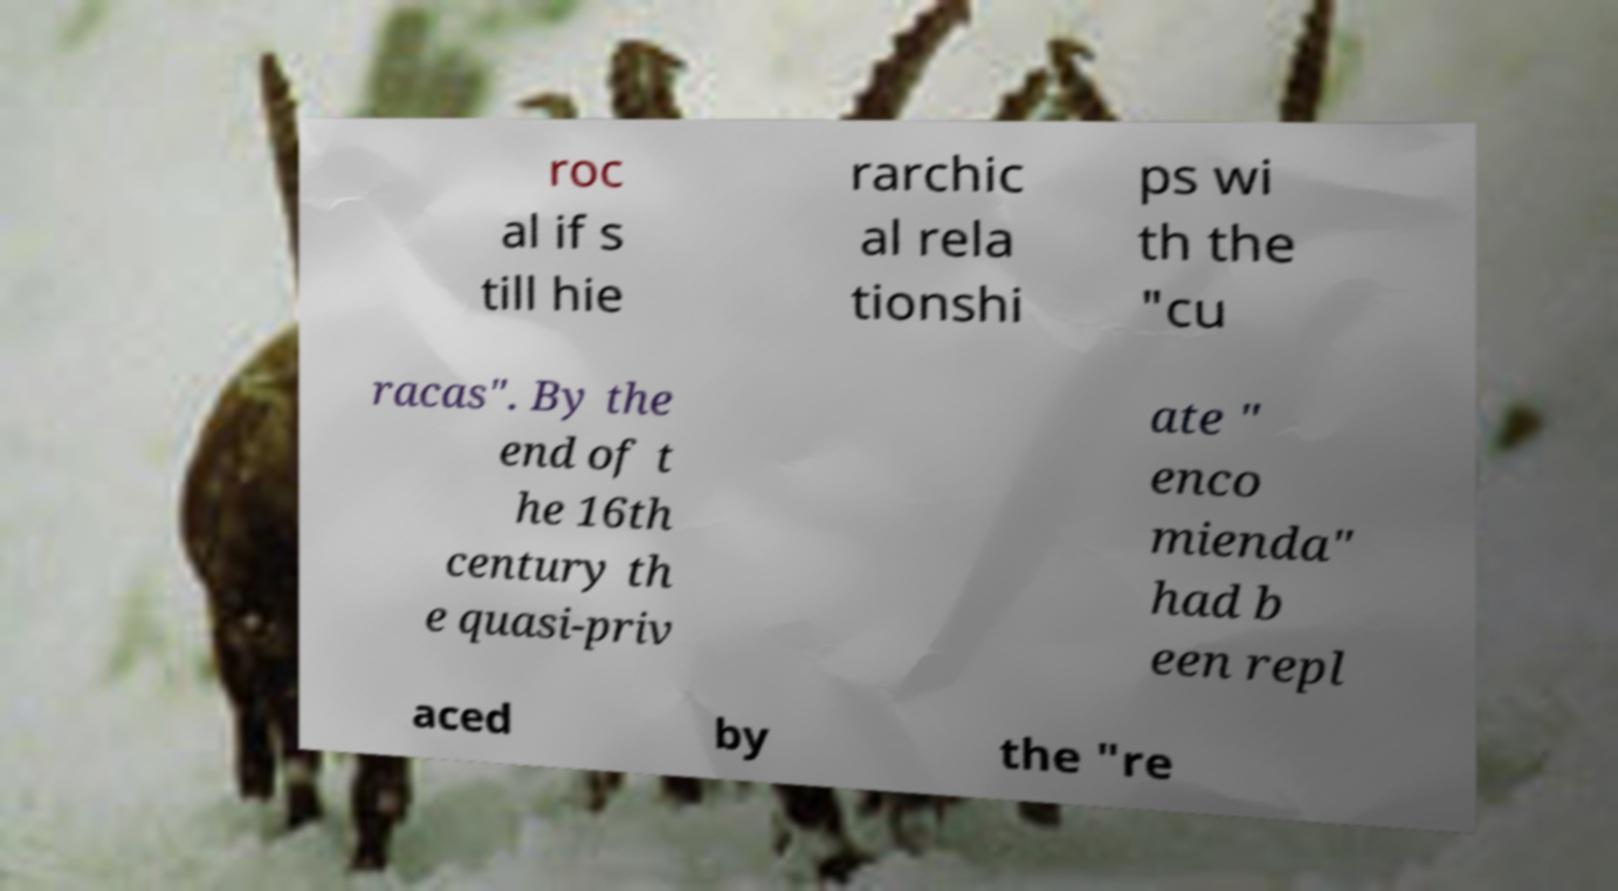Can you read and provide the text displayed in the image?This photo seems to have some interesting text. Can you extract and type it out for me? roc al if s till hie rarchic al rela tionshi ps wi th the "cu racas". By the end of t he 16th century th e quasi-priv ate " enco mienda" had b een repl aced by the "re 